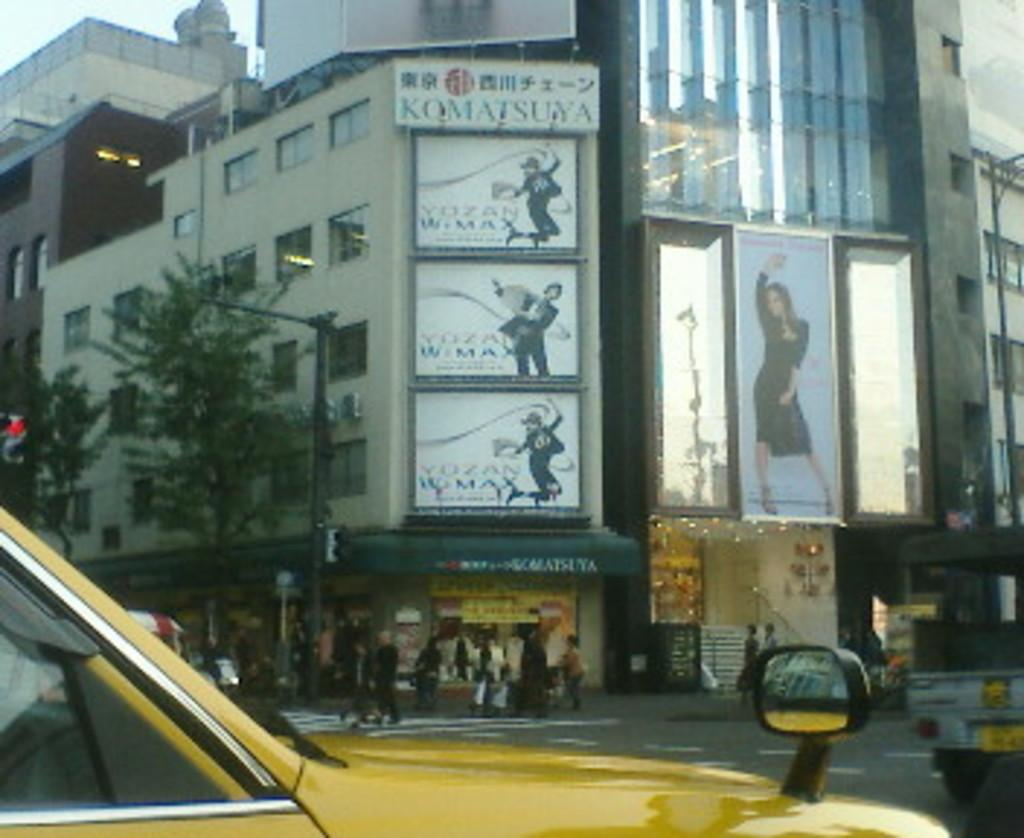Provide a one-sentence caption for the provided image. A yellow vehicle in front of some signs, one of which reads Komatsuya. 